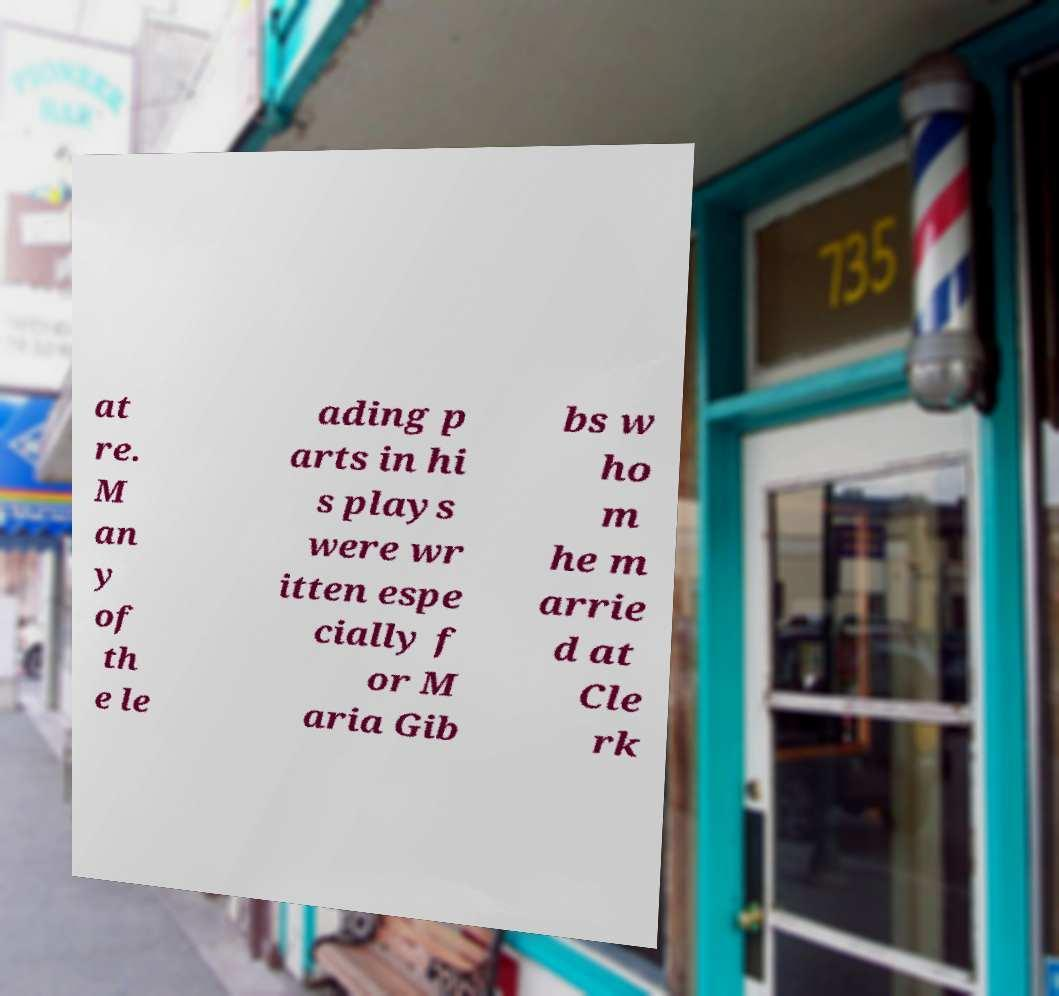Could you assist in decoding the text presented in this image and type it out clearly? at re. M an y of th e le ading p arts in hi s plays were wr itten espe cially f or M aria Gib bs w ho m he m arrie d at Cle rk 